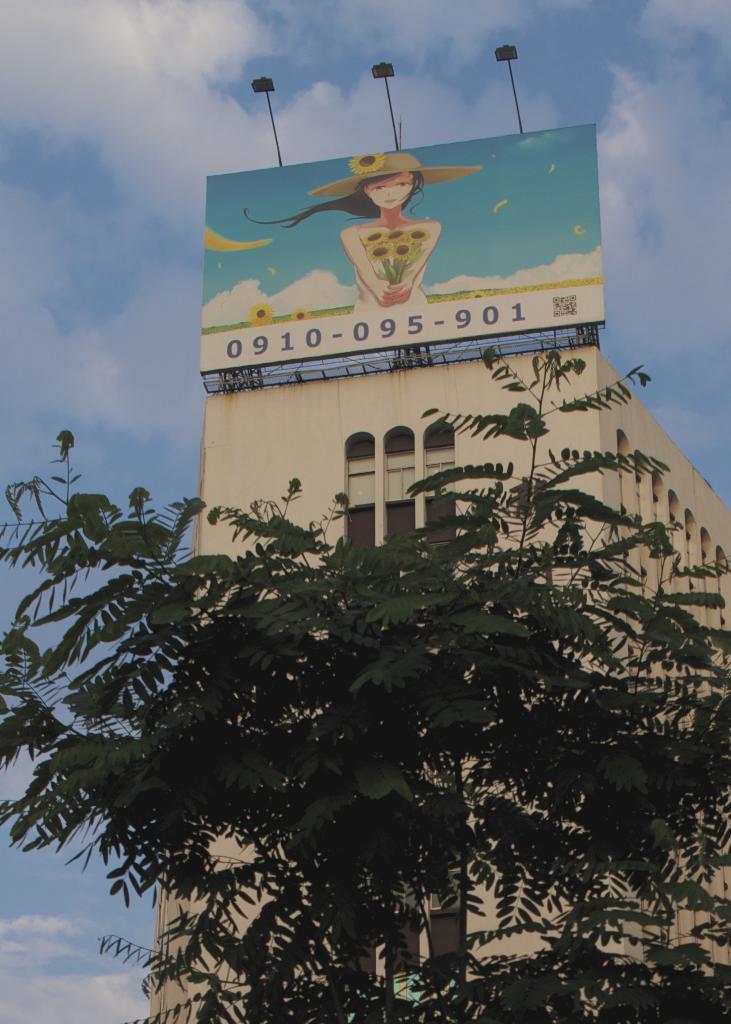Please provide a concise description of this image. In this image I can see few trees in green color. In the background I can see the building, board, few lights and the sky is in blue and white color. 